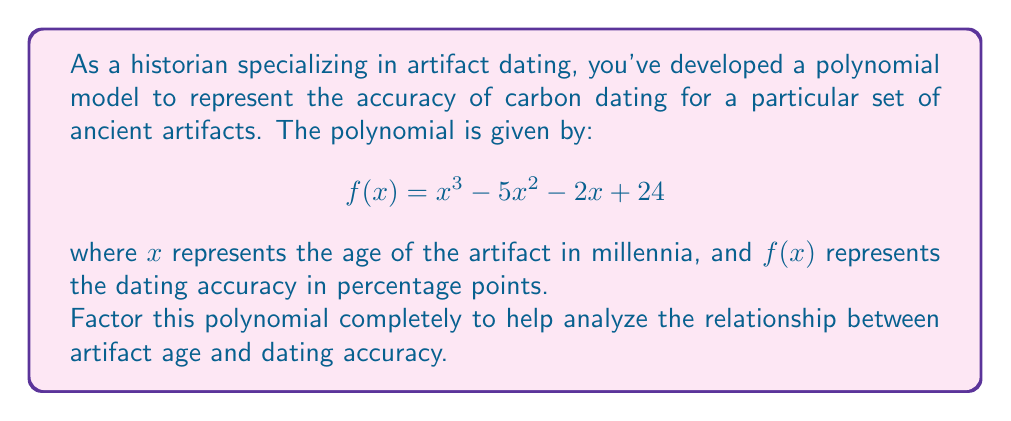Help me with this question. To factor this polynomial, we'll follow these steps:

1) First, let's check if there are any rational roots using the rational root theorem. The possible rational roots are the factors of the constant term: $\pm 1, \pm 2, \pm 3, \pm 4, \pm 6, \pm 8, \pm 12, \pm 24$.

2) Testing these values, we find that $f(4) = 0$. So $(x-4)$ is a factor.

3) We can use polynomial long division to divide $f(x)$ by $(x-4)$:

   $$\frac{x^3 - 5x^2 - 2x + 24}{x - 4} = x^2 - x - 6$$

4) Now we have: $f(x) = (x-4)(x^2 - x - 6)$

5) The quadratic factor $x^2 - x - 6$ can be factored further:
   
   $x^2 - x - 6 = (x-3)(x+2)$

6) Combining all factors, we get:

   $$f(x) = (x-4)(x-3)(x+2)$$

This is the complete factorization of the polynomial.
Answer: $f(x) = (x-4)(x-3)(x+2)$ 